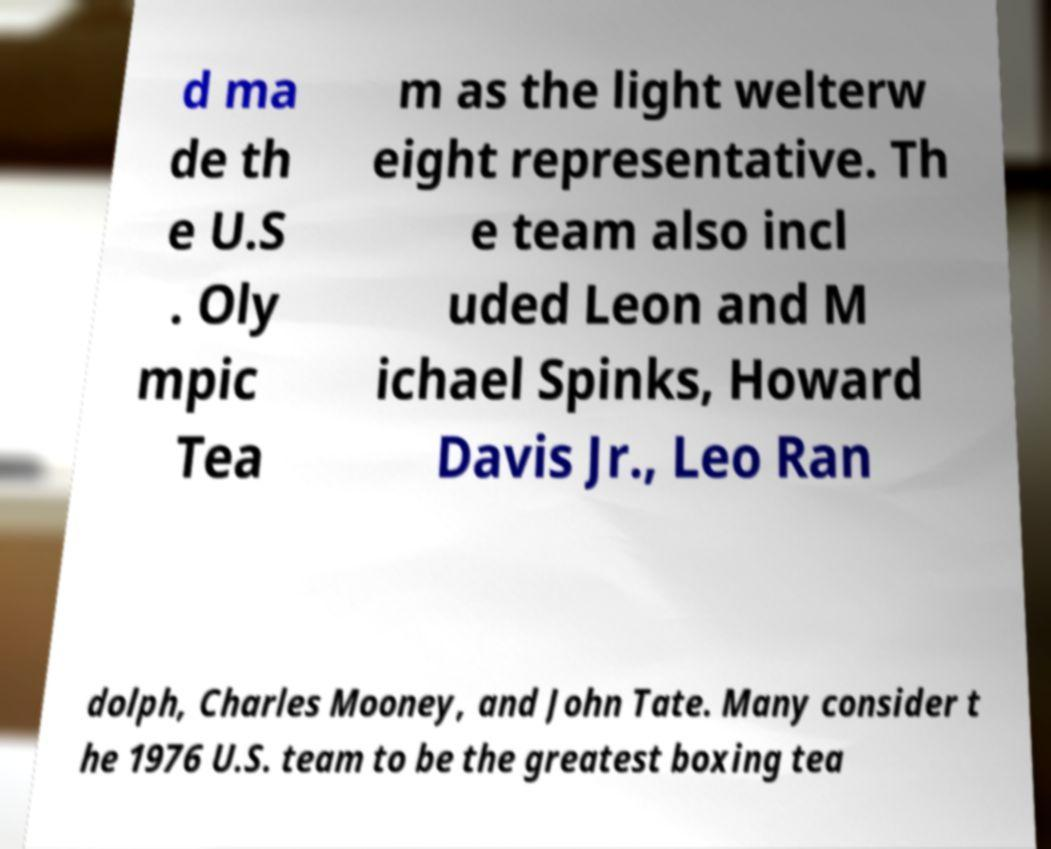There's text embedded in this image that I need extracted. Can you transcribe it verbatim? d ma de th e U.S . Oly mpic Tea m as the light welterw eight representative. Th e team also incl uded Leon and M ichael Spinks, Howard Davis Jr., Leo Ran dolph, Charles Mooney, and John Tate. Many consider t he 1976 U.S. team to be the greatest boxing tea 